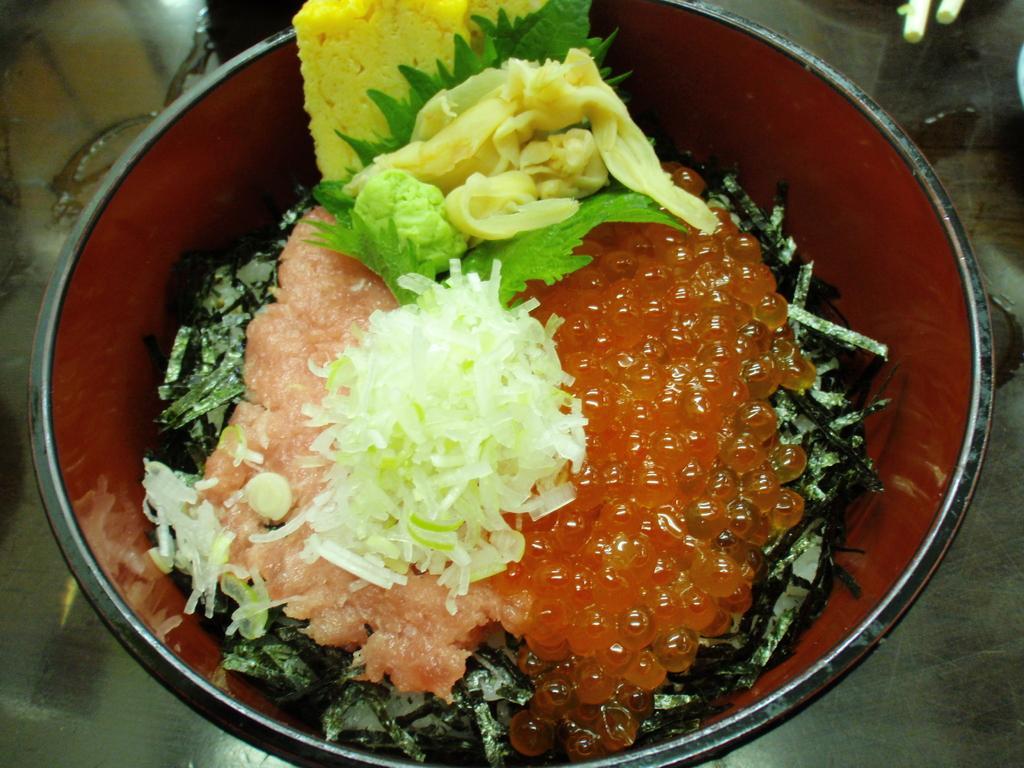Could you give a brief overview of what you see in this image? In this picture we can see a bowl of food kept on a table. 